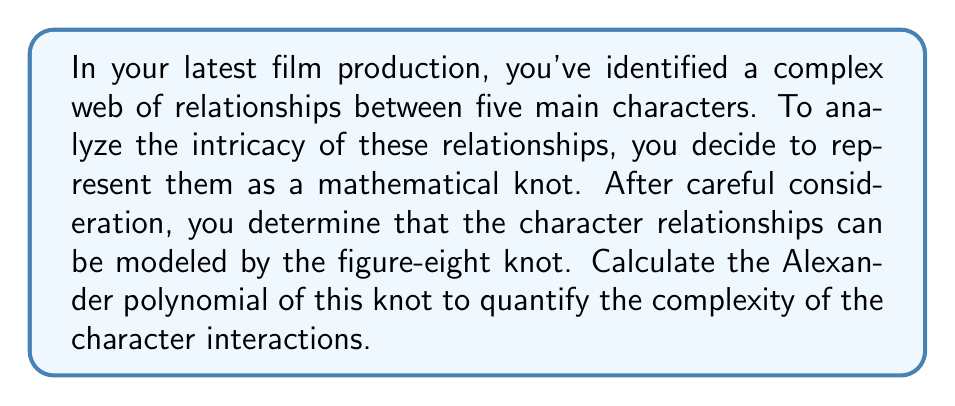Show me your answer to this math problem. To compute the Alexander polynomial of the figure-eight knot, we'll follow these steps:

1. First, we need to create a knot diagram. The figure-eight knot can be represented as:

[asy]
import geometry;

path p = (0,0){right}..{down}(1,-1)..{left}(0,-2)..{up}(-1,-1)..{right}(0,0);
path q = (0,0){left}..{down}(-1,-1)..{right}(0,-2)..{up}(1,-1)..{left}(0,0);

draw(p,blue+1);
draw(q,red+1);

dot((0,0));
dot((0,-2));
[/asy]

2. Label the arcs and crossings:

[asy]
import geometry;

path p = (0,0){right}..{down}(1,-1)..{left}(0,-2)..{up}(-1,-1)..{right}(0,0);
path q = (0,0){left}..{down}(-1,-1)..{right}(0,-2)..{up}(1,-1)..{left}(0,0);

draw(p,blue+1);
draw(q,red+1);

dot((0,0));
dot((0,-2));

label("a", (0.5,0), N);
label("b", (-0.5,0), N);
label("c", (0,-1), E);
label("d", (0,-1), W);

label("1", (0.7,-0.7), SE);
label("2", (-0.7,-0.7), SW);
label("3", (-0.7,-1.3), NW);
label("4", (0.7,-1.3), NE);
[/asy]

3. Create the Alexander matrix. For each crossing, we write an equation:

   Crossing 1: $a - tb + (t-1)c = 0$
   Crossing 2: $b - td + (t-1)a = 0$
   Crossing 3: $c - ta + (t-1)d = 0$
   Crossing 4: $d - tc + (t-1)b = 0$

4. Form the matrix:

   $$
   \begin{pmatrix}
   1 & -t & t-1 & 0 \\
   t-1 & 1 & 0 & -t \\
   -t & 0 & 1 & t-1 \\
   0 & t-1 & -t & 1
   \end{pmatrix}
   $$

5. Delete any row and column to get a 3x3 matrix. Let's delete the last row and column:

   $$
   \begin{pmatrix}
   1 & -t & t-1 \\
   t-1 & 1 & 0 \\
   -t & 0 & 1
   \end{pmatrix}
   $$

6. Calculate the determinant of this matrix:

   $\det = 1 \cdot 1 \cdot 1 + (-t) \cdot 0 \cdot (t-1) + (t-1) \cdot (t-1) \cdot (-t) - (t-1) \cdot 1 \cdot (-t) - 1 \cdot 0 \cdot 1 - 1 \cdot (t-1) \cdot (t-1)$

7. Simplify:

   $\det = 1 + 0 + (t^3 - 2t^2 + t) + (t^2 - t) - 0 - (t^2 - 2t + 1)$
   $\det = t^3 - t^2 + t - 1$

8. The Alexander polynomial is the absolute value of this determinant:

   $\Delta(t) = |t^3 - t^2 + t - 1|$
Answer: $\Delta(t) = |t^3 - t^2 + t - 1|$ 